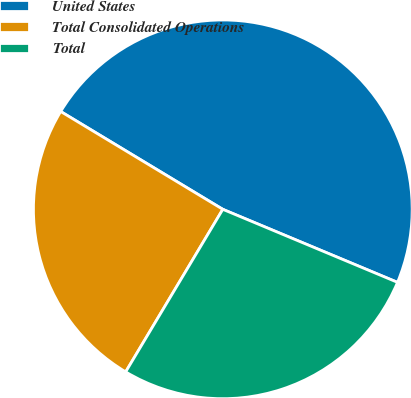Convert chart to OTSL. <chart><loc_0><loc_0><loc_500><loc_500><pie_chart><fcel>United States<fcel>Total Consolidated Operations<fcel>Total<nl><fcel>47.66%<fcel>25.07%<fcel>27.27%<nl></chart> 